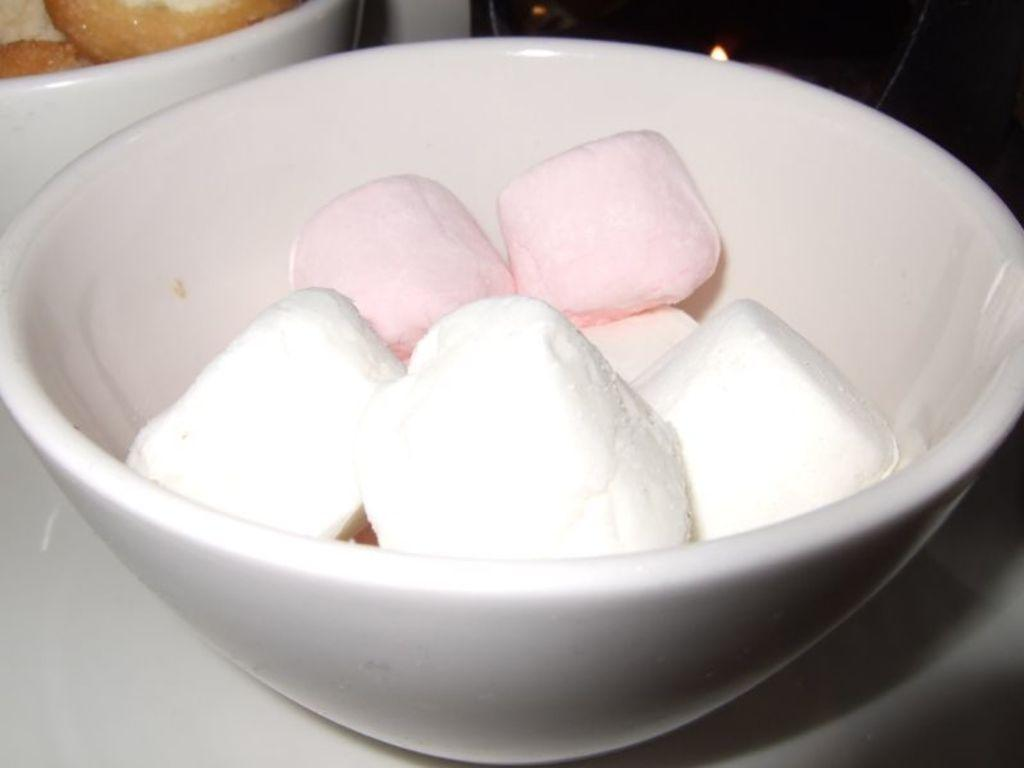What type of food is visible in the image? There are marshmallows in the image. What colors are the marshmallows? The marshmallows are in white and pink colors. Where are the marshmallows located? The marshmallows are in a bowl. What is the color of the bowl? The bowl is white in color. What title is given to the marshmallows in the image? There is no title given to the marshmallows in the image. Can you touch the marshmallows in the image? It is not possible to touch the marshmallows in the image, as it is a two-dimensional representation. 